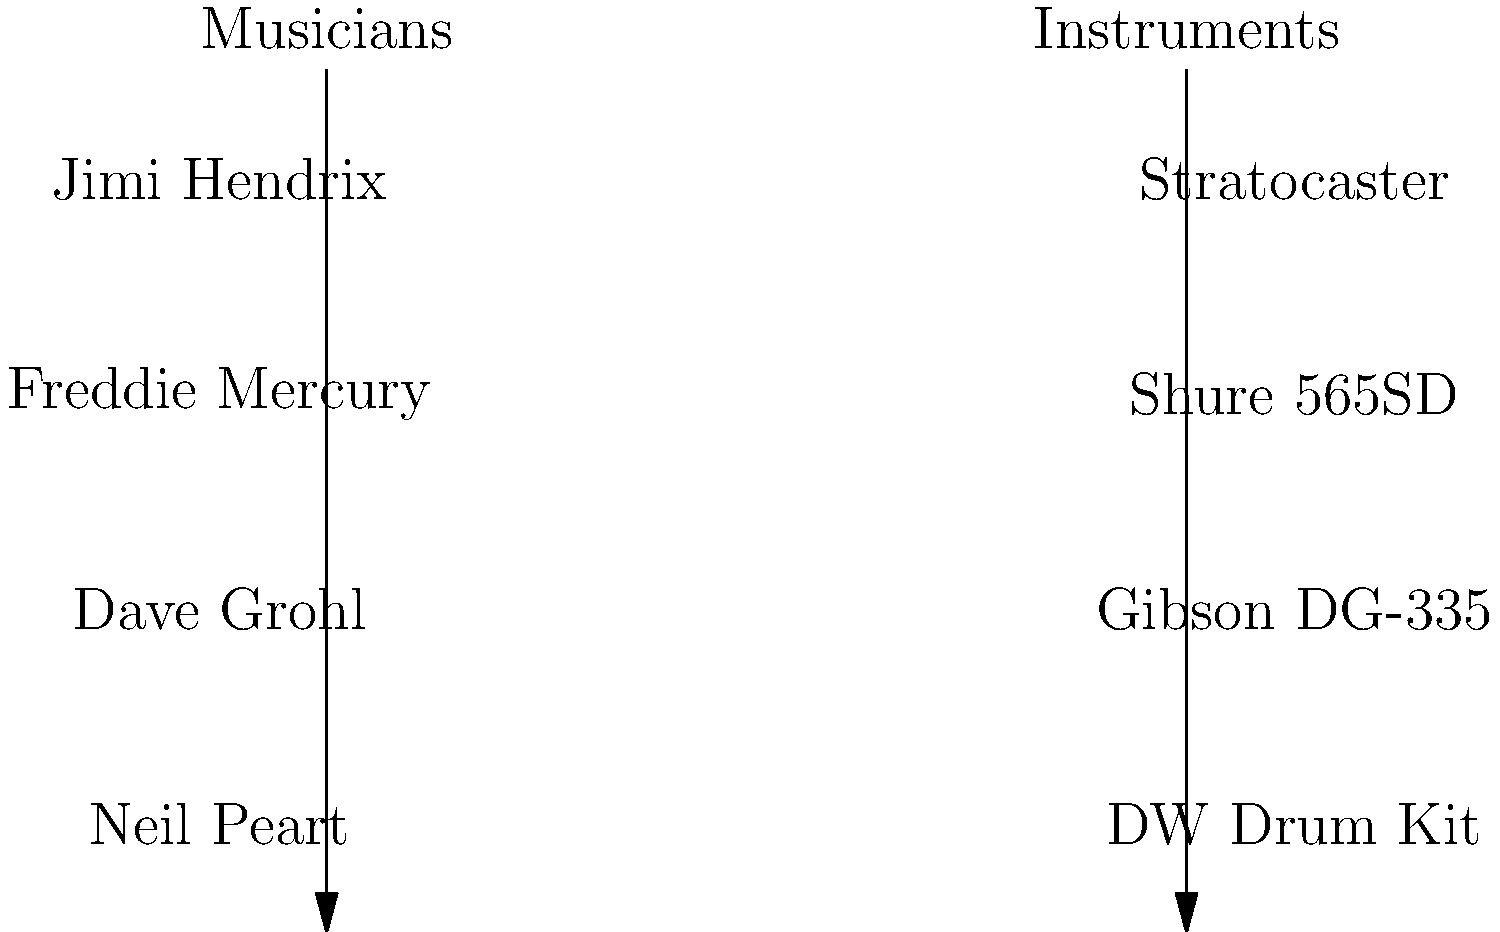Match the following musicians to their signature instruments or microphones:

1. Jimi Hendrix
2. Freddie Mercury
3. Dave Grohl
4. Neil Peart

A. Gibson DG-335
B. DW Drum Kit
C. Stratocaster
D. Shure 565SD Step 1: Jimi Hendrix
Jimi Hendrix was known for his virtuosic guitar playing, particularly on the Fender Stratocaster. The Stratocaster became his signature instrument, and he used it to create his iconic sound.

Step 2: Freddie Mercury
As the lead vocalist of Queen, Freddie Mercury was often seen using the Shure 565SD microphone. This microphone became closely associated with his powerful and dynamic performances.

Step 3: Dave Grohl
While Dave Grohl is known for his drumming in Nirvana, he's also the frontman and guitarist for Foo Fighters. His signature guitar is the Gibson DG-335, a custom model designed specifically for him.

Step 4: Neil Peart
Neil Peart, the legendary drummer of Rush, was known for his extensive and elaborate drum kits. In his later years, he used a custom DW (Drum Workshop) Drum Kit, which became his signature instrument.

Therefore, the correct matching is:
1-C, 2-D, 3-A, 4-B
Answer: 1-C, 2-D, 3-A, 4-B 